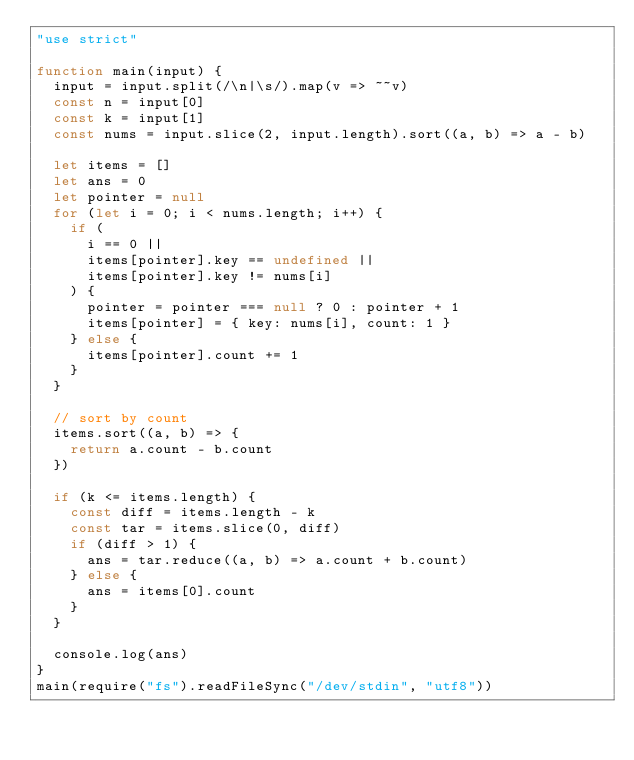Convert code to text. <code><loc_0><loc_0><loc_500><loc_500><_JavaScript_>"use strict"

function main(input) {
  input = input.split(/\n|\s/).map(v => ~~v)
  const n = input[0]
  const k = input[1]
  const nums = input.slice(2, input.length).sort((a, b) => a - b)

  let items = []
  let ans = 0
  let pointer = null
  for (let i = 0; i < nums.length; i++) {
    if (
      i == 0 ||
      items[pointer].key == undefined ||
      items[pointer].key != nums[i]
    ) {
      pointer = pointer === null ? 0 : pointer + 1
      items[pointer] = { key: nums[i], count: 1 }
    } else {
      items[pointer].count += 1
    }
  }

  // sort by count
  items.sort((a, b) => {
    return a.count - b.count
  })

  if (k <= items.length) {
    const diff = items.length - k
    const tar = items.slice(0, diff)
    if (diff > 1) {
      ans = tar.reduce((a, b) => a.count + b.count)
    } else {
      ans = items[0].count
    }
  }

  console.log(ans)
}
main(require("fs").readFileSync("/dev/stdin", "utf8"))
</code> 